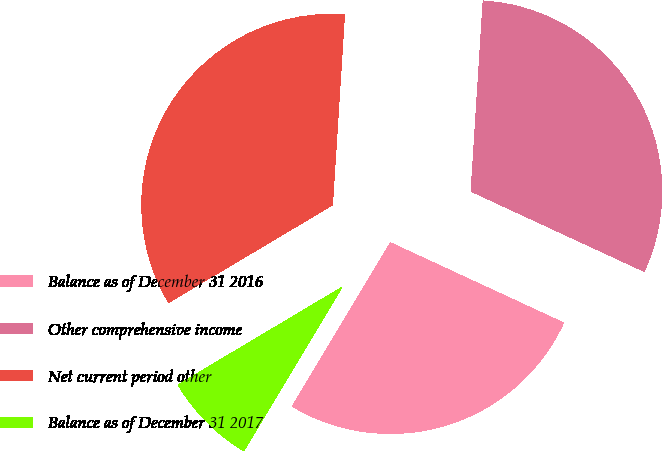Convert chart. <chart><loc_0><loc_0><loc_500><loc_500><pie_chart><fcel>Balance as of December 31 2016<fcel>Other comprehensive income<fcel>Net current period other<fcel>Balance as of December 31 2017<nl><fcel>26.7%<fcel>30.89%<fcel>34.55%<fcel>7.85%<nl></chart> 